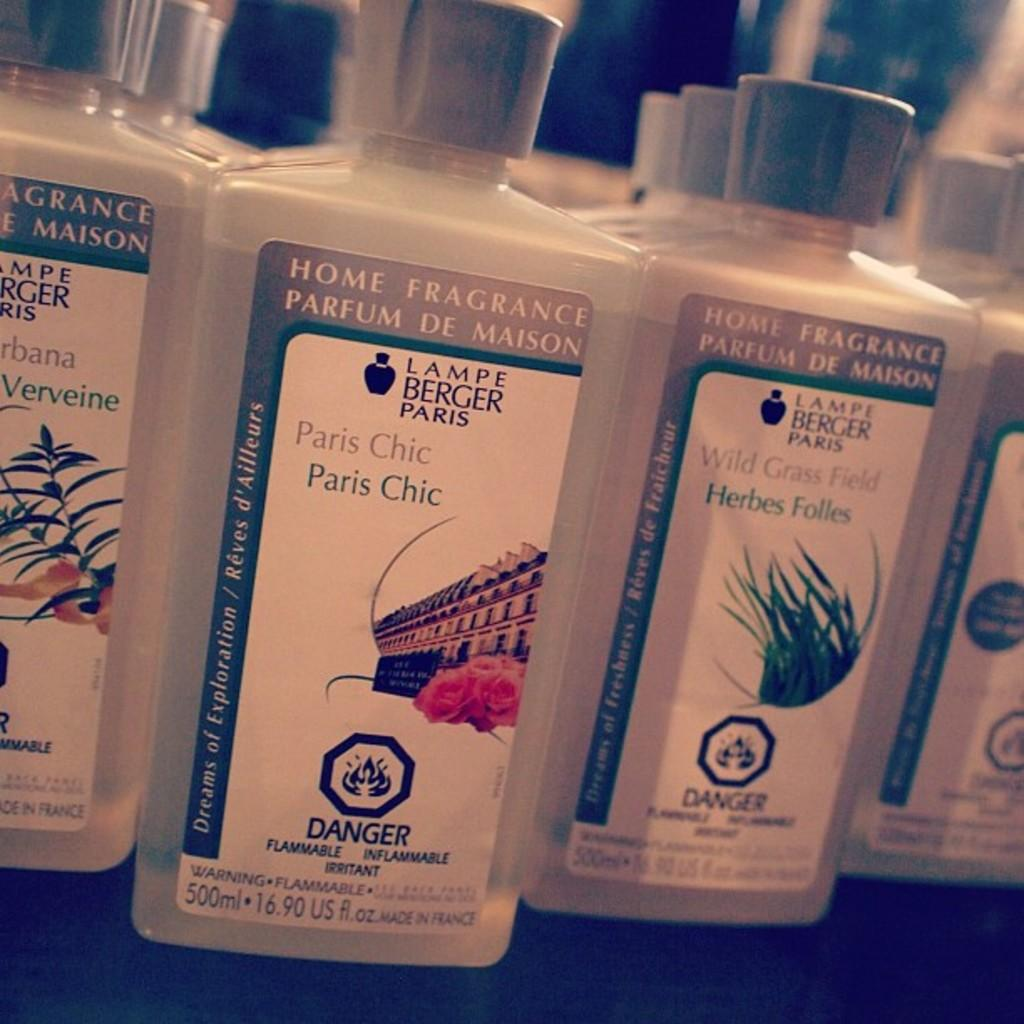<image>
Write a terse but informative summary of the picture. a few bottles, one with paris chic on it 